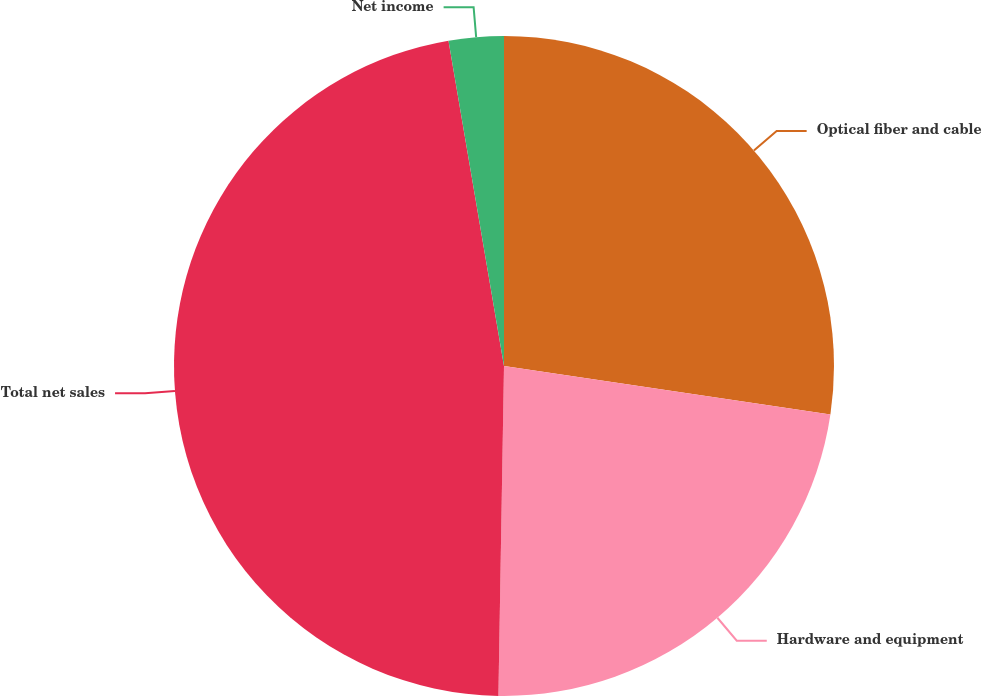Convert chart to OTSL. <chart><loc_0><loc_0><loc_500><loc_500><pie_chart><fcel>Optical fiber and cable<fcel>Hardware and equipment<fcel>Total net sales<fcel>Net income<nl><fcel>27.35%<fcel>22.92%<fcel>47.04%<fcel>2.69%<nl></chart> 